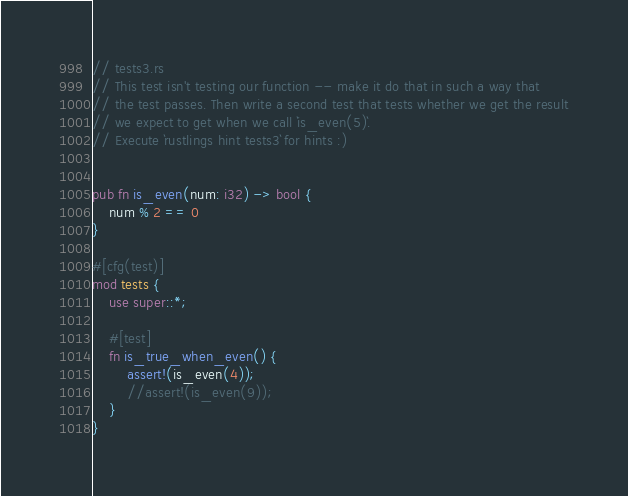<code> <loc_0><loc_0><loc_500><loc_500><_Rust_>// tests3.rs
// This test isn't testing our function -- make it do that in such a way that
// the test passes. Then write a second test that tests whether we get the result
// we expect to get when we call `is_even(5)`.
// Execute `rustlings hint tests3` for hints :)


pub fn is_even(num: i32) -> bool {
    num % 2 == 0
}

#[cfg(test)]
mod tests {
    use super::*;

    #[test]
    fn is_true_when_even() {
        assert!(is_even(4));
        //assert!(is_even(9));
    }
}
</code> 